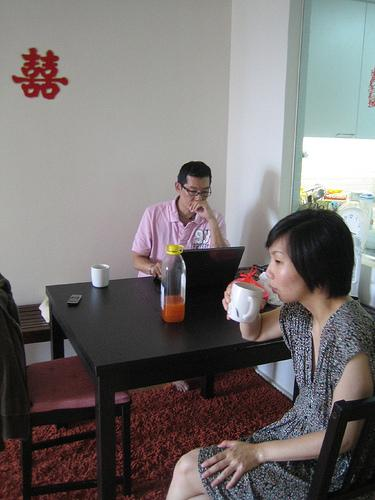Why is the woman blowing on the mug? hot 